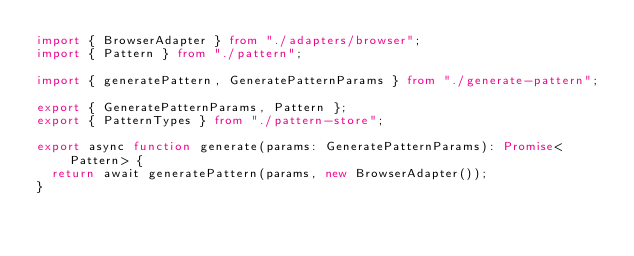Convert code to text. <code><loc_0><loc_0><loc_500><loc_500><_TypeScript_>import { BrowserAdapter } from "./adapters/browser";
import { Pattern } from "./pattern";

import { generatePattern, GeneratePatternParams } from "./generate-pattern";

export { GeneratePatternParams, Pattern };
export { PatternTypes } from "./pattern-store";

export async function generate(params: GeneratePatternParams): Promise<Pattern> {
  return await generatePattern(params, new BrowserAdapter());
}
</code> 